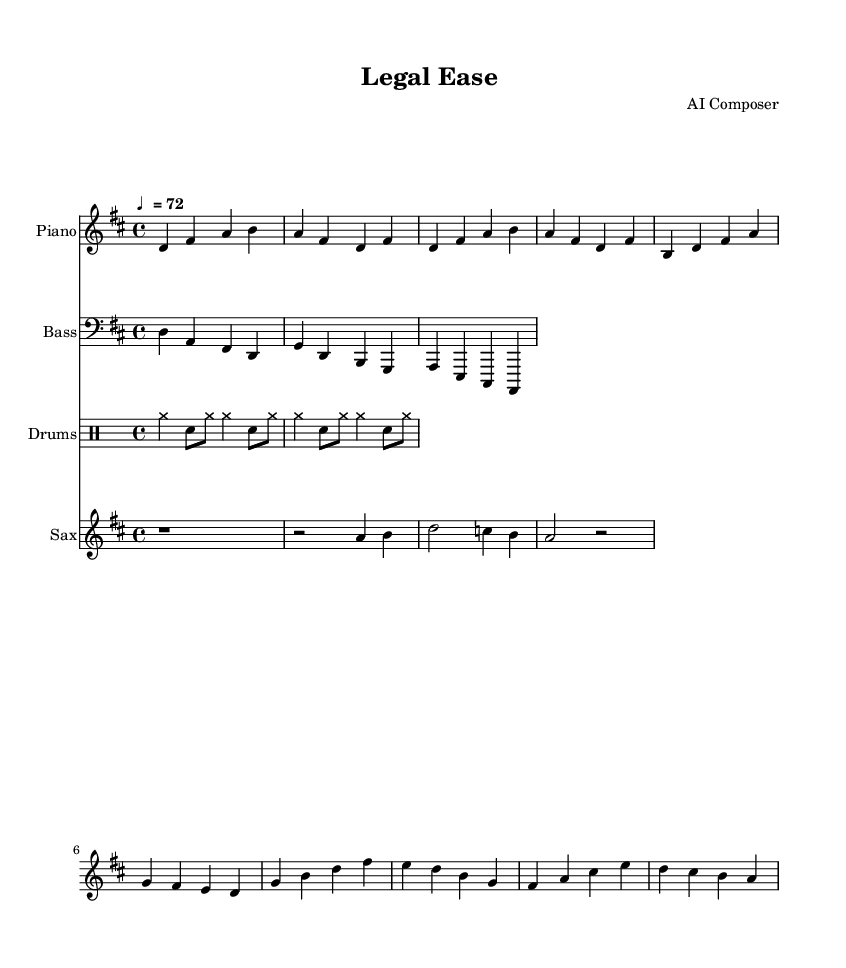What is the key signature of this music? The key signature is D major, which has two sharps (F# and C#). This can be determined by looking for the sharp symbols at the beginning of the staff before the notes start.
Answer: D major What is the time signature of this music? The time signature is 4/4, which means there are four beats in a measure and a quarter note gets one beat. This is indicated at the beginning of the staff as a fraction.
Answer: 4/4 What is the tempo marking of this music? The tempo marking is ♩ = 72, meaning the quarter note is set to a speed of 72 beats per minute. This is shown at the start of the score near the global settings.
Answer: 72 What instrument plays the main melody in the score? The main melody is played by the saxophone, as indicated by the specific staff labeled "Sax" and the notes written on that staff.
Answer: Saxophone How many measures are in the verse section of this music? The verse section consists of four measures, identifiable by counting the number of bar lines separating the notes in that section.
Answer: Four measures What type of rhythm pattern does the drum part use? The drum part uses a simple pattern of cymbals and snare hits, which can be deduced by looking at the symbols in the drummode section and noting the alternating rhythms.
Answer: Simple drum pattern What is the emotional quality intended by this style of music? The emotional quality can be described as relaxing and soothing, which is characteristic of smooth jazz-influenced R&B; this is inferred from the harmonic progression and the laid-back tempo.
Answer: Relaxing 